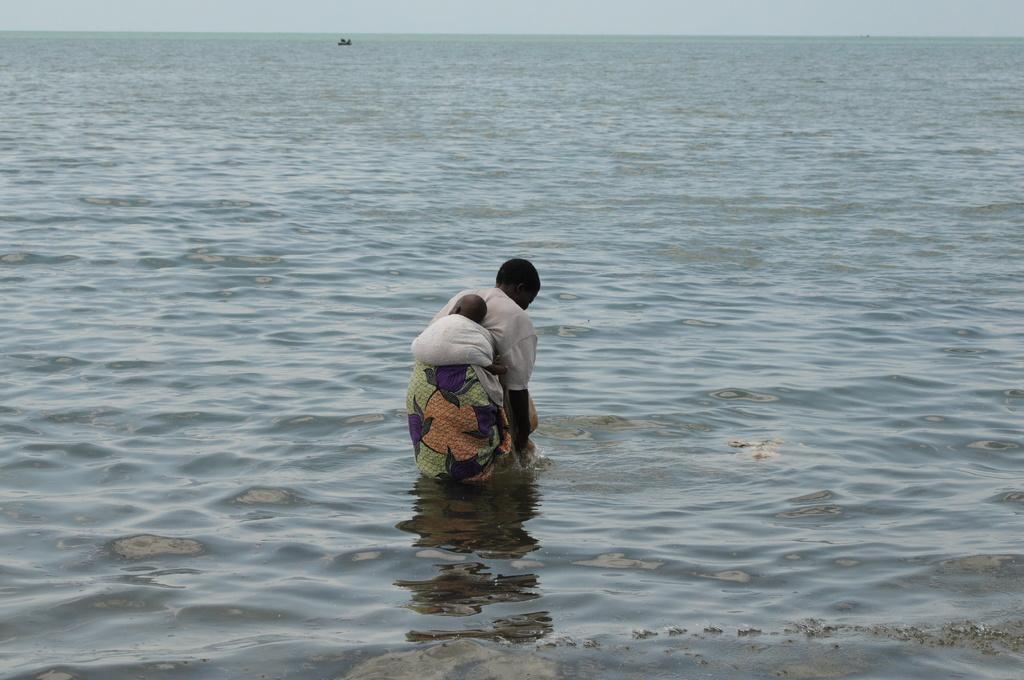Describe this image in one or two sentences. At the bottom of this image, there is water. In this water, there is a woman having a baby tied with a cloth to her. In the background, there is a boat on the water and the sky. 